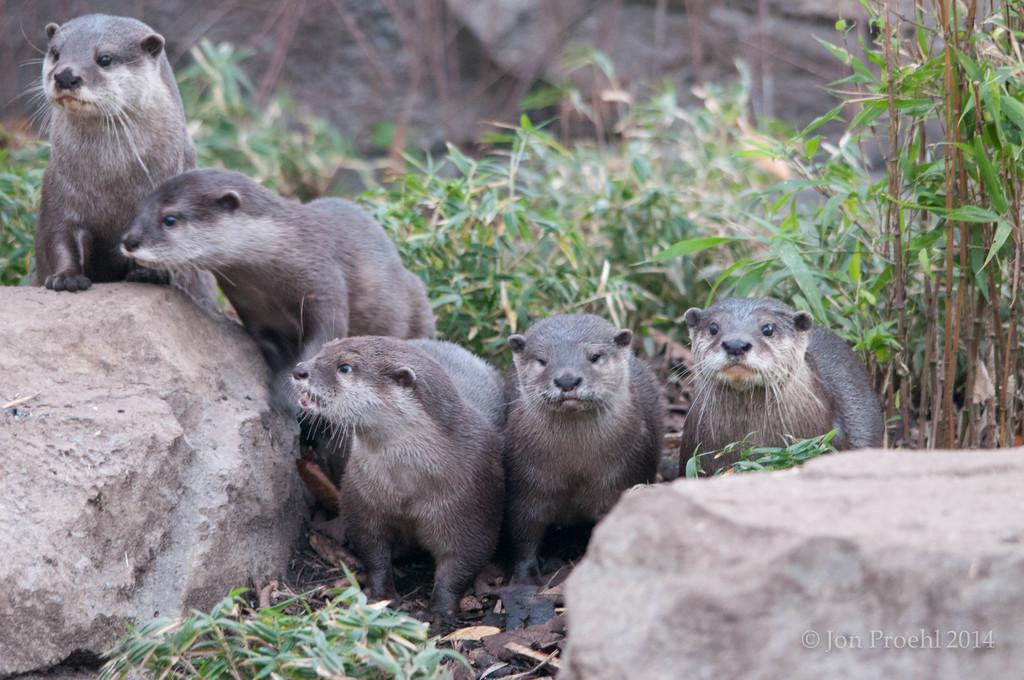What types of living organisms can be seen in the image? There are animals in the image. What can be seen in the bottom left corner of the image? There is a rock in the bottom left of the image. What can be seen in the bottom right corner of the image? There is a rock in the bottom right of the image. What is located in the middle of the image? There are plants in the middle of the image. What type of instrument is the animal playing in the image? There is no instrument present in the image, and the animals are not playing any instruments. 